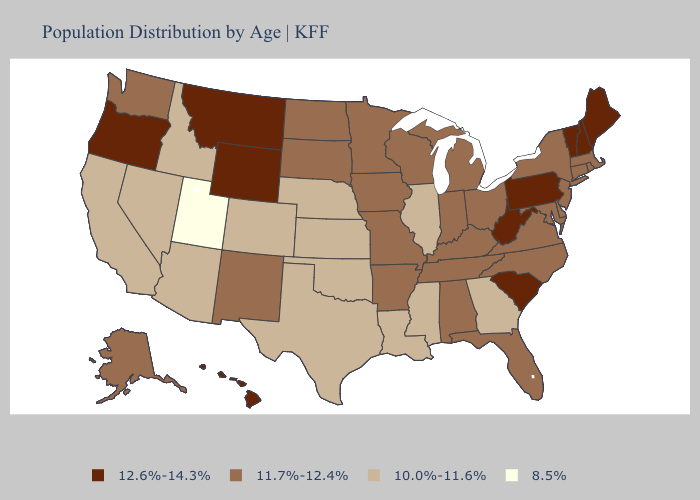Does Virginia have the lowest value in the South?
Write a very short answer. No. Does Missouri have the same value as Mississippi?
Write a very short answer. No. Name the states that have a value in the range 11.7%-12.4%?
Quick response, please. Alabama, Alaska, Arkansas, Connecticut, Delaware, Florida, Indiana, Iowa, Kentucky, Maryland, Massachusetts, Michigan, Minnesota, Missouri, New Jersey, New Mexico, New York, North Carolina, North Dakota, Ohio, Rhode Island, South Dakota, Tennessee, Virginia, Washington, Wisconsin. Name the states that have a value in the range 11.7%-12.4%?
Keep it brief. Alabama, Alaska, Arkansas, Connecticut, Delaware, Florida, Indiana, Iowa, Kentucky, Maryland, Massachusetts, Michigan, Minnesota, Missouri, New Jersey, New Mexico, New York, North Carolina, North Dakota, Ohio, Rhode Island, South Dakota, Tennessee, Virginia, Washington, Wisconsin. Does Pennsylvania have the lowest value in the Northeast?
Answer briefly. No. Which states have the lowest value in the USA?
Be succinct. Utah. What is the lowest value in states that border Maryland?
Keep it brief. 11.7%-12.4%. What is the lowest value in the West?
Give a very brief answer. 8.5%. Does Arizona have a higher value than Wyoming?
Write a very short answer. No. What is the lowest value in the USA?
Keep it brief. 8.5%. Does New York have the lowest value in the USA?
Keep it brief. No. How many symbols are there in the legend?
Be succinct. 4. What is the lowest value in the USA?
Keep it brief. 8.5%. Does Hawaii have the highest value in the USA?
Answer briefly. Yes. Name the states that have a value in the range 8.5%?
Give a very brief answer. Utah. 